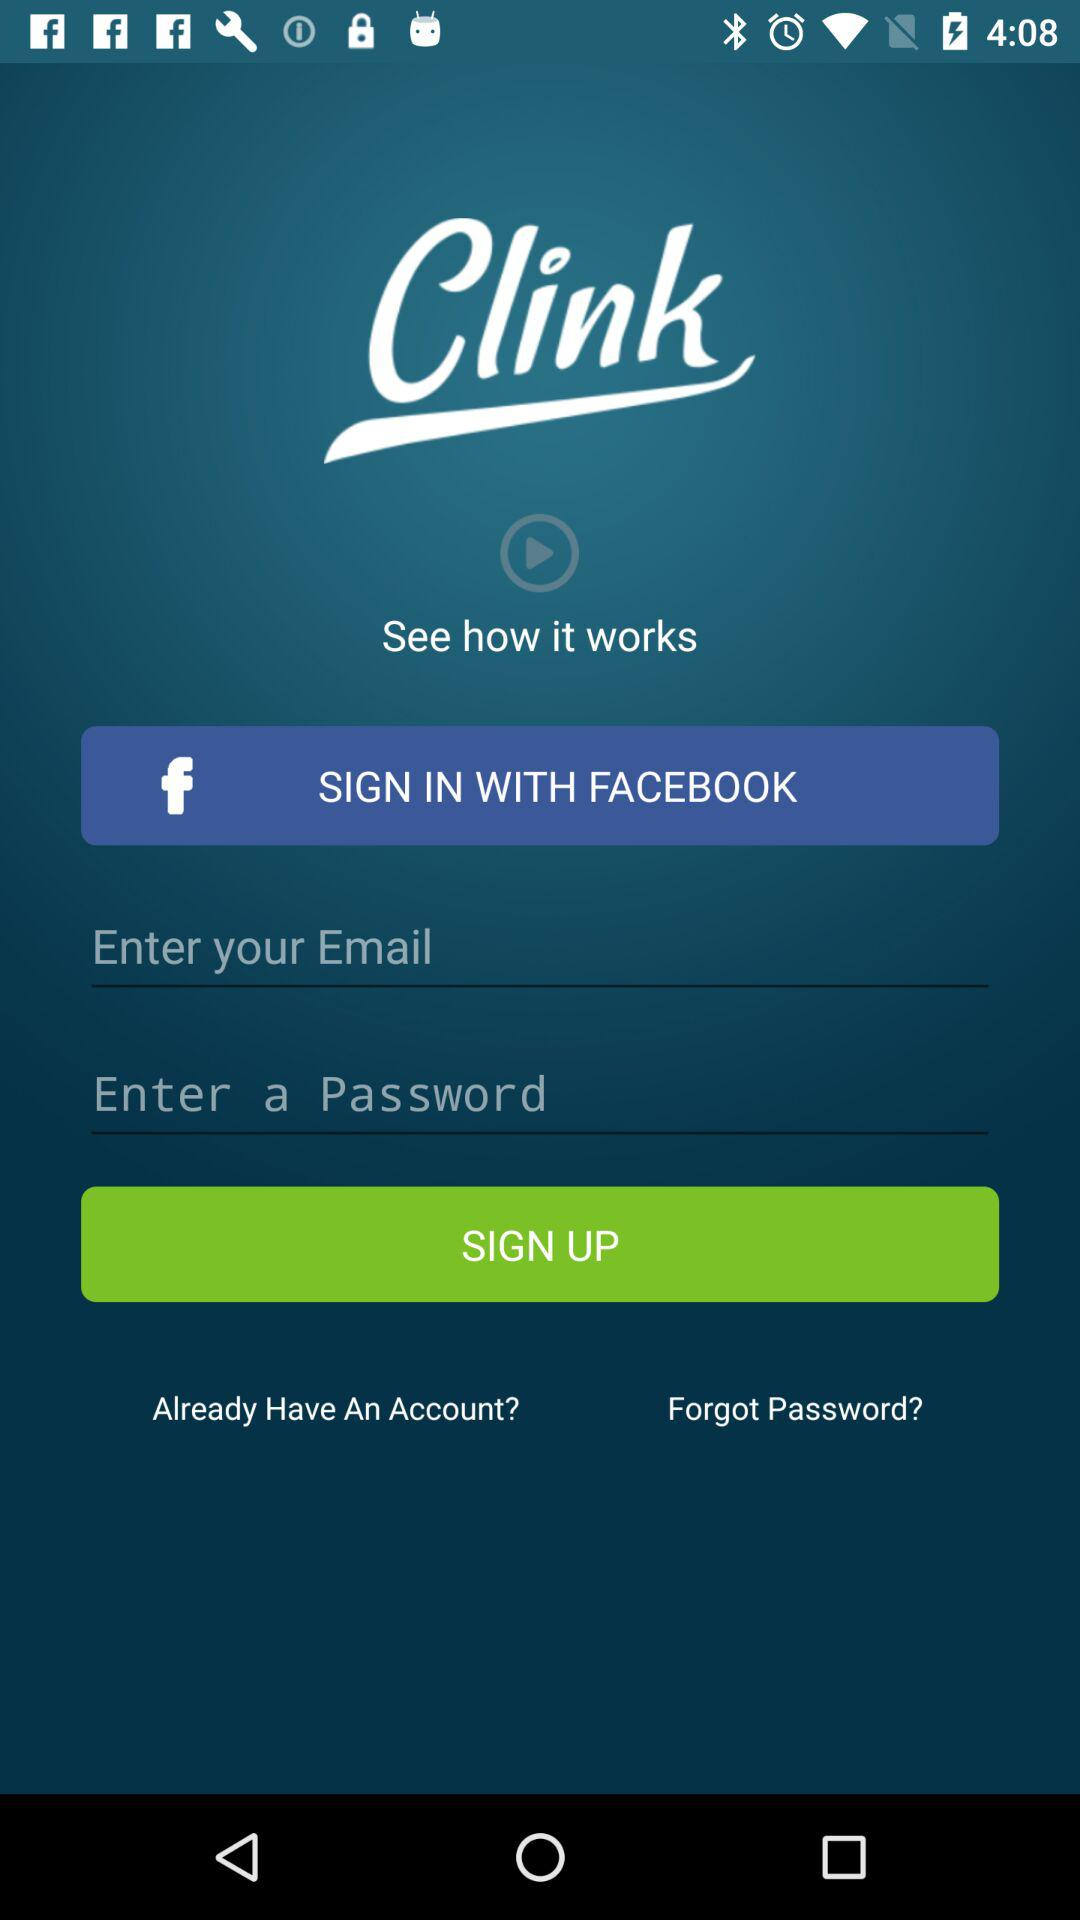What is the application name? The application name is "Clink". 